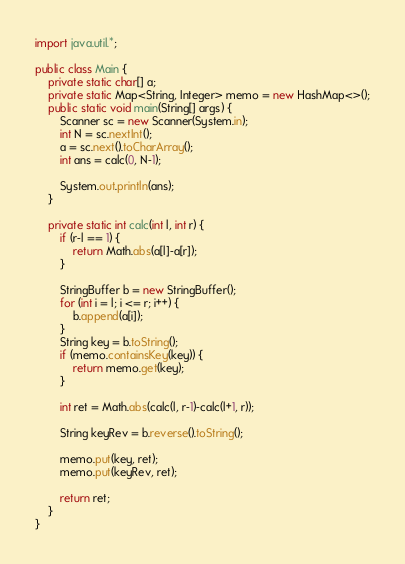Convert code to text. <code><loc_0><loc_0><loc_500><loc_500><_Java_>import java.util.*;

public class Main {
    private static char[] a;
    private static Map<String, Integer> memo = new HashMap<>();
    public static void main(String[] args) {
        Scanner sc = new Scanner(System.in);
        int N = sc.nextInt();
        a = sc.next().toCharArray();
        int ans = calc(0, N-1);

        System.out.println(ans);
    }

    private static int calc(int l, int r) {
        if (r-l == 1) {
            return Math.abs(a[l]-a[r]);
        }

        StringBuffer b = new StringBuffer();
        for (int i = l; i <= r; i++) {
            b.append(a[i]);
        }
        String key = b.toString();
        if (memo.containsKey(key)) {
            return memo.get(key);
        }

        int ret = Math.abs(calc(l, r-1)-calc(l+1, r));

        String keyRev = b.reverse().toString();

        memo.put(key, ret);
        memo.put(keyRev, ret);
 
        return ret;
    }
}

</code> 